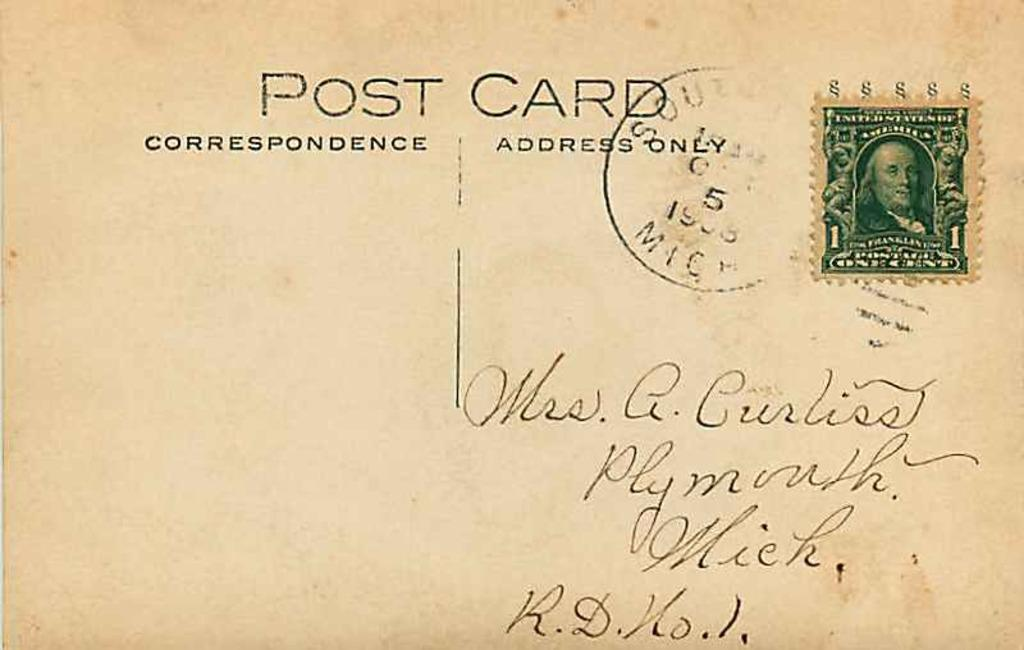<image>
Provide a brief description of the given image. A post card has been sent to someone for a penny. 